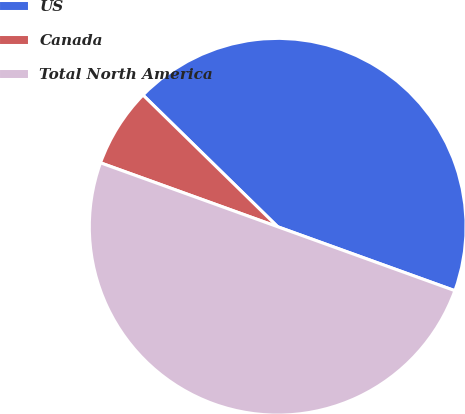Convert chart to OTSL. <chart><loc_0><loc_0><loc_500><loc_500><pie_chart><fcel>US<fcel>Canada<fcel>Total North America<nl><fcel>43.19%<fcel>6.81%<fcel>50.0%<nl></chart> 